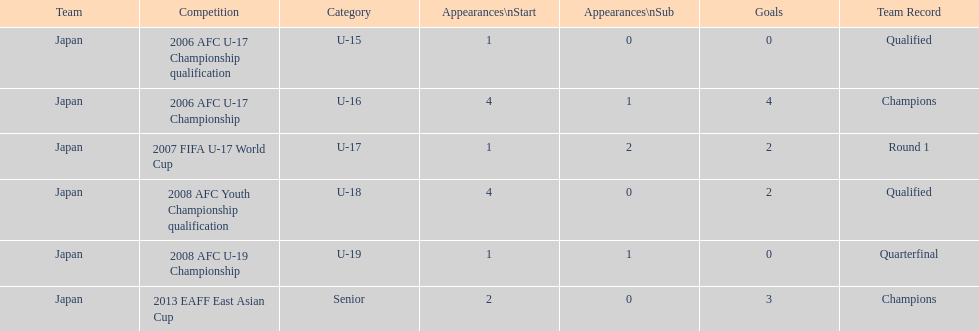Where did japan merely score four goals? 2006 AFC U-17 Championship. Could you help me parse every detail presented in this table? {'header': ['Team', 'Competition', 'Category', 'Appearances\\nStart', 'Appearances\\nSub', 'Goals', 'Team Record'], 'rows': [['Japan', '2006 AFC U-17 Championship qualification', 'U-15', '1', '0', '0', 'Qualified'], ['Japan', '2006 AFC U-17 Championship', 'U-16', '4', '1', '4', 'Champions'], ['Japan', '2007 FIFA U-17 World Cup', 'U-17', '1', '2', '2', 'Round 1'], ['Japan', '2008 AFC Youth Championship qualification', 'U-18', '4', '0', '2', 'Qualified'], ['Japan', '2008 AFC U-19 Championship', 'U-19', '1', '1', '0', 'Quarterfinal'], ['Japan', '2013 EAFF East Asian Cup', 'Senior', '2', '0', '3', 'Champions']]} 